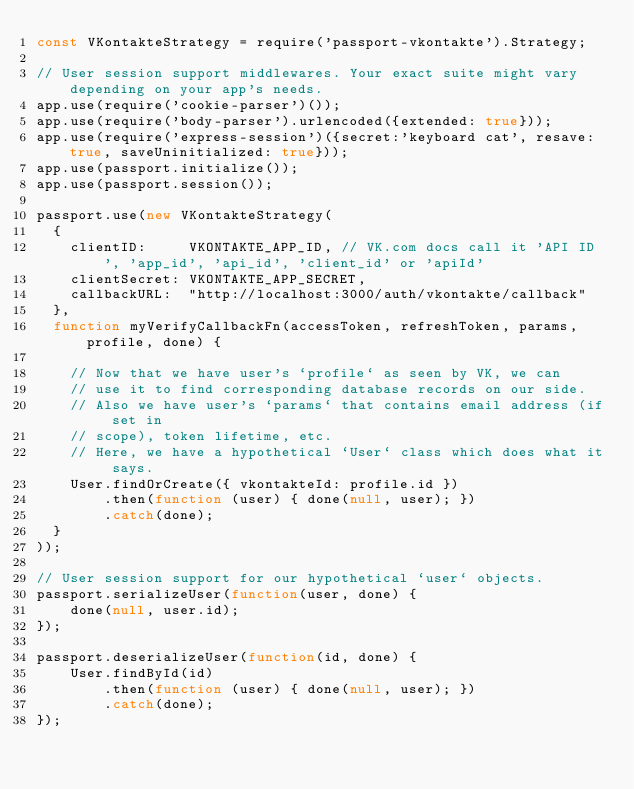Convert code to text. <code><loc_0><loc_0><loc_500><loc_500><_JavaScript_>const VKontakteStrategy = require('passport-vkontakte').Strategy;

// User session support middlewares. Your exact suite might vary depending on your app's needs.
app.use(require('cookie-parser')());
app.use(require('body-parser').urlencoded({extended: true}));
app.use(require('express-session')({secret:'keyboard cat', resave: true, saveUninitialized: true}));
app.use(passport.initialize());
app.use(passport.session());

passport.use(new VKontakteStrategy(
  {
    clientID:     VKONTAKTE_APP_ID, // VK.com docs call it 'API ID', 'app_id', 'api_id', 'client_id' or 'apiId'
    clientSecret: VKONTAKTE_APP_SECRET,
    callbackURL:  "http://localhost:3000/auth/vkontakte/callback"
  },
  function myVerifyCallbackFn(accessToken, refreshToken, params, profile, done) {

    // Now that we have user's `profile` as seen by VK, we can
    // use it to find corresponding database records on our side.
    // Also we have user's `params` that contains email address (if set in 
    // scope), token lifetime, etc.
    // Here, we have a hypothetical `User` class which does what it says.
    User.findOrCreate({ vkontakteId: profile.id })
        .then(function (user) { done(null, user); })
        .catch(done);
  }
));

// User session support for our hypothetical `user` objects.
passport.serializeUser(function(user, done) {
    done(null, user.id);
});

passport.deserializeUser(function(id, done) {
    User.findById(id)
        .then(function (user) { done(null, user); })
        .catch(done);
});
</code> 